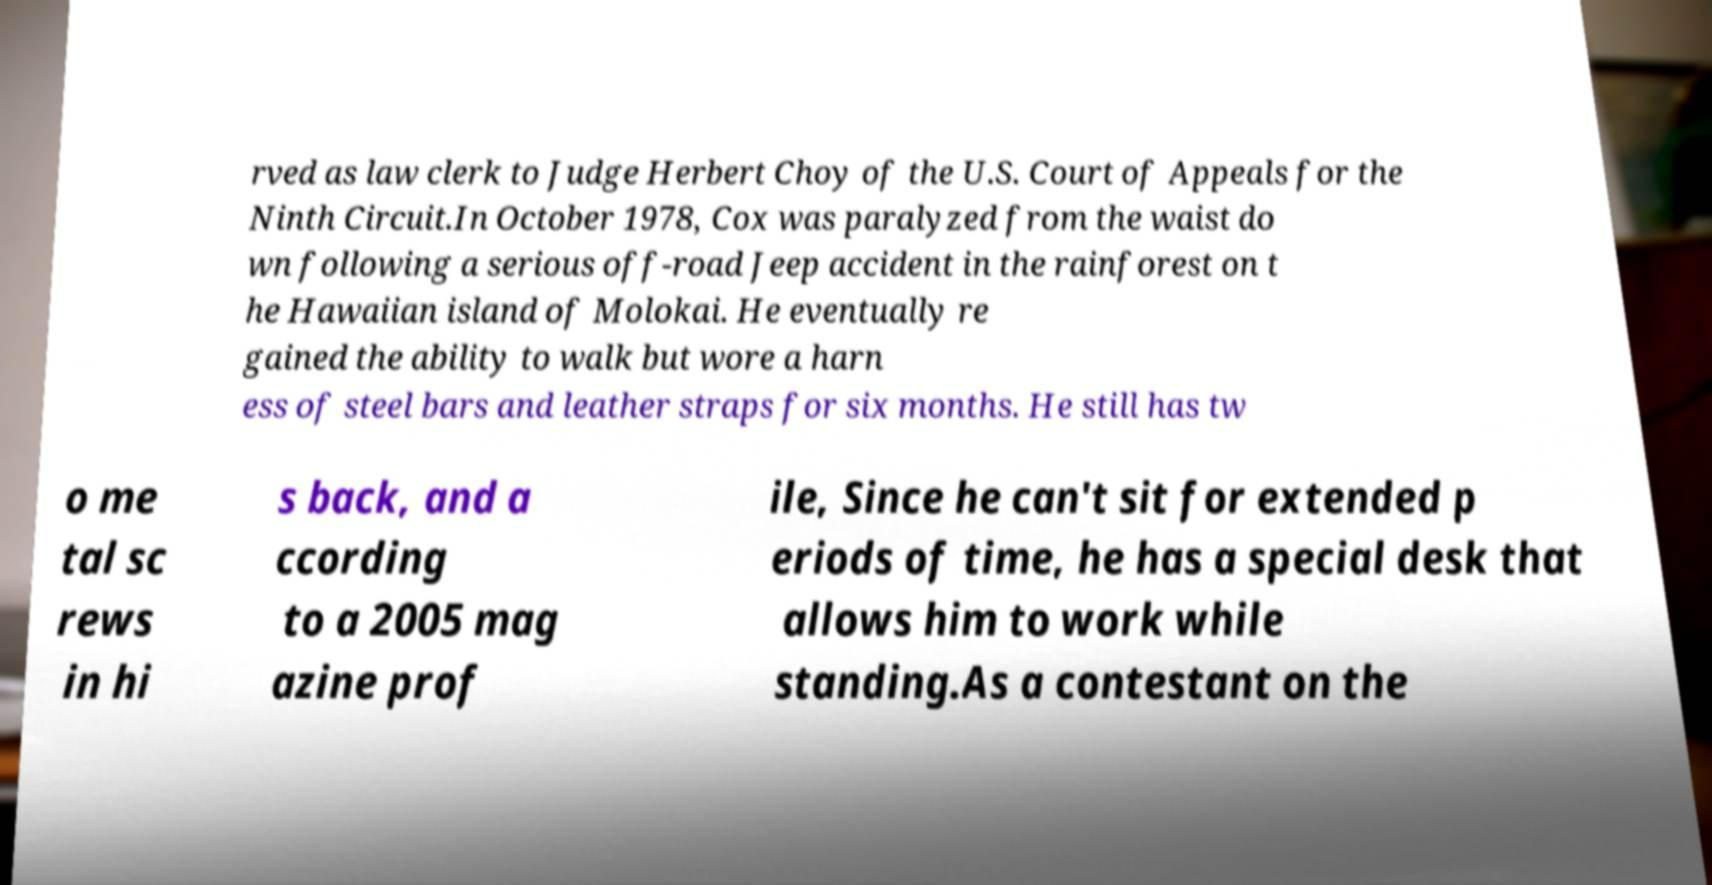What messages or text are displayed in this image? I need them in a readable, typed format. rved as law clerk to Judge Herbert Choy of the U.S. Court of Appeals for the Ninth Circuit.In October 1978, Cox was paralyzed from the waist do wn following a serious off-road Jeep accident in the rainforest on t he Hawaiian island of Molokai. He eventually re gained the ability to walk but wore a harn ess of steel bars and leather straps for six months. He still has tw o me tal sc rews in hi s back, and a ccording to a 2005 mag azine prof ile, Since he can't sit for extended p eriods of time, he has a special desk that allows him to work while standing.As a contestant on the 